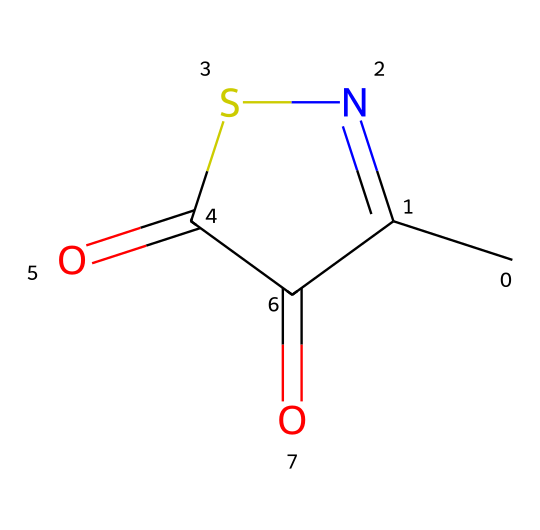What is the molecular formula of methylisothiazolinone? To find the molecular formula, we identify the number of each type of atom present in the SMILES. The breakdown reveals: 4 Carbon (C), 4 Hydrogen (H), 1 Nitrogen (N), and 2 Oxygen (O). Therefore, the molecular formula is C4H4N2O2.
Answer: C4H4N2O2 How many rings are present in the structure? Analyzing the SMILES representation, we see the characters 'C1' and 'C1=' which indicate that there’s a cyclic structure. Thus, the compound contains one ring.
Answer: 1 What functional groups are present in methylisothiazolinone? By examining the structure, we can observe a carbonyl group (C=O) and a thiazole ring with a nitrogen atom. These indicate the presence of both a carbonyl and a thiazolinone functional group.
Answer: carbonyl and thiazolinone What is the total number of atoms in the structure? Counting each atom depicted in the chemical structure from the SMILES, we have 4 Carbons, 4 Hydrogens, 1 Nitrogen, and 2 Oxygens, totaling to 11 atoms: 4 + 4 + 1 + 2 = 11.
Answer: 11 Is methylisothiazolinone a natural or synthetic preservative? Methylisothiazolinone is known to be a synthetic preservative, commonly used in cosmetic and cleaning products. This conclusion is drawn from its widespread use and the nature of its synthetic production.
Answer: synthetic What is the role of methylisothiazolinone in cleaning products? Methylisothiazolinone serves as a preservative in cleaning products by preventing microbial growth and thereby extending product shelf life. This is a common function of preservatives, ensuring products remain effective and safe to use.
Answer: preservative 